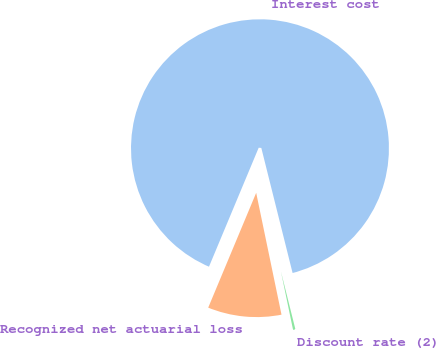<chart> <loc_0><loc_0><loc_500><loc_500><pie_chart><fcel>Interest cost<fcel>Recognized net actuarial loss<fcel>Discount rate (2)<nl><fcel>89.8%<fcel>9.56%<fcel>0.64%<nl></chart> 